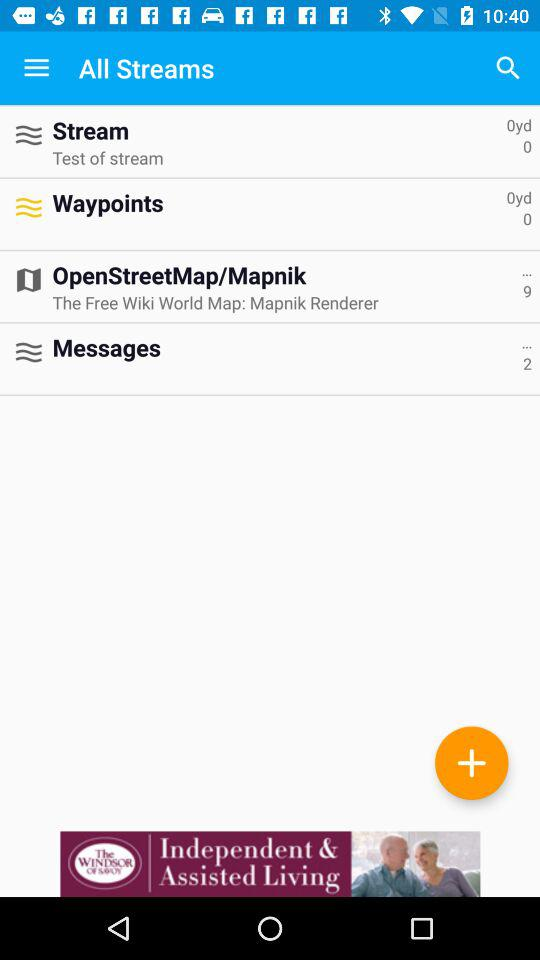What is the given length of the stream? The given length of the stream is 0 yards. 